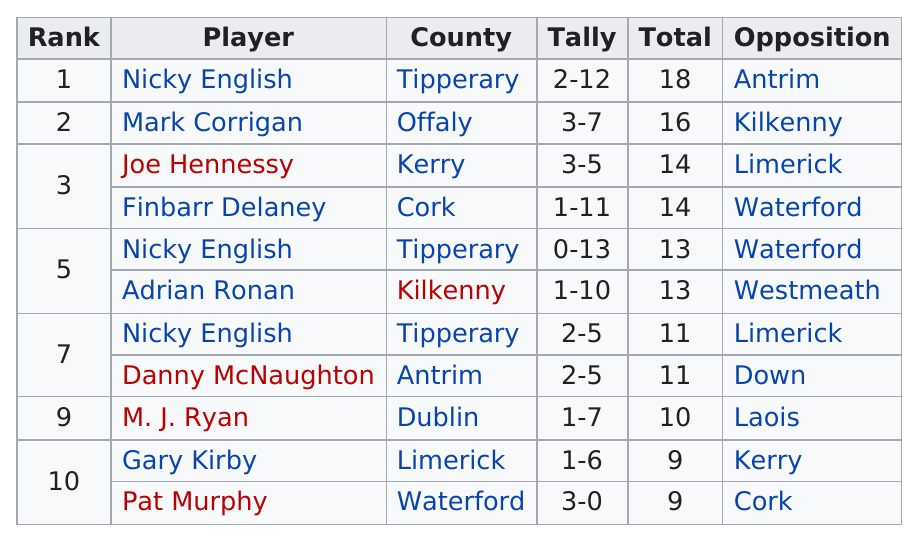Mention a couple of crucial points in this snapshot. Joe Hennessy and Finbarr Delaney each scored 14 points. The first name on the list is Nicky English. The player who ranked the most is Nicky English. Mark Corrigan was ranked above by someone named Nicky English. The average of the totals of Nicky English and Mark Corrigan was 17. 